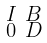Convert formula to latex. <formula><loc_0><loc_0><loc_500><loc_500>\begin{smallmatrix} I & B \\ 0 & D \end{smallmatrix}</formula> 